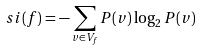Convert formula to latex. <formula><loc_0><loc_0><loc_500><loc_500>s i ( f ) = - \sum _ { v \in V _ { f } } P ( v ) \log _ { 2 } P ( v )</formula> 